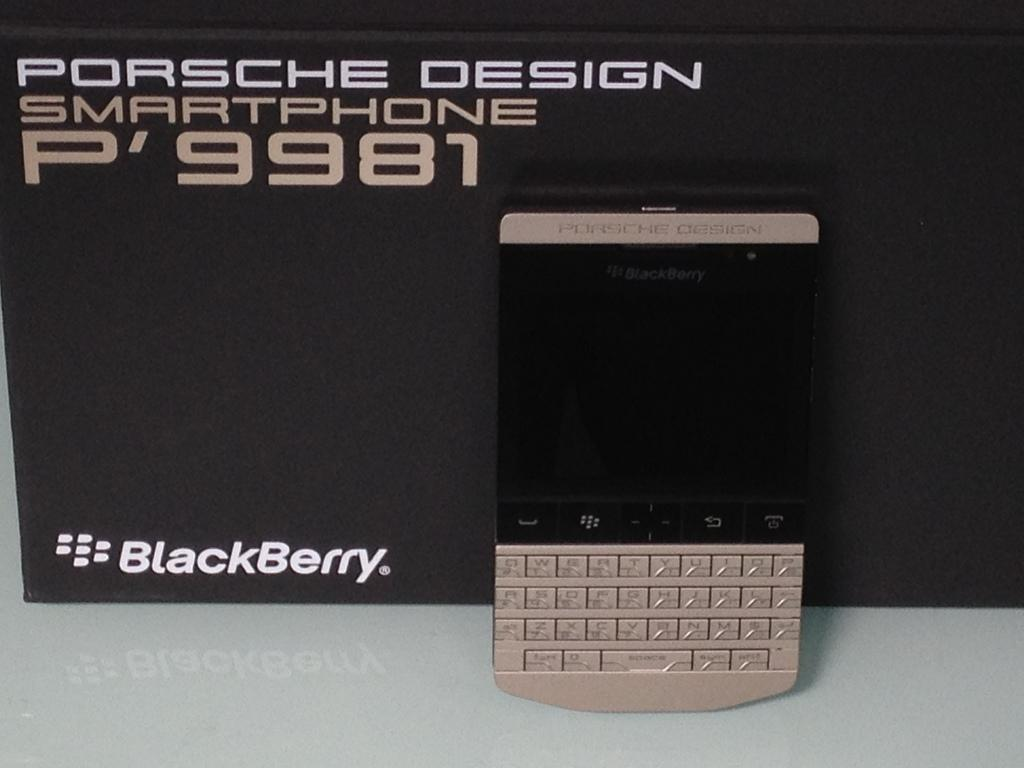<image>
Give a short and clear explanation of the subsequent image. a smartphone with a p'9981 sign on the front 